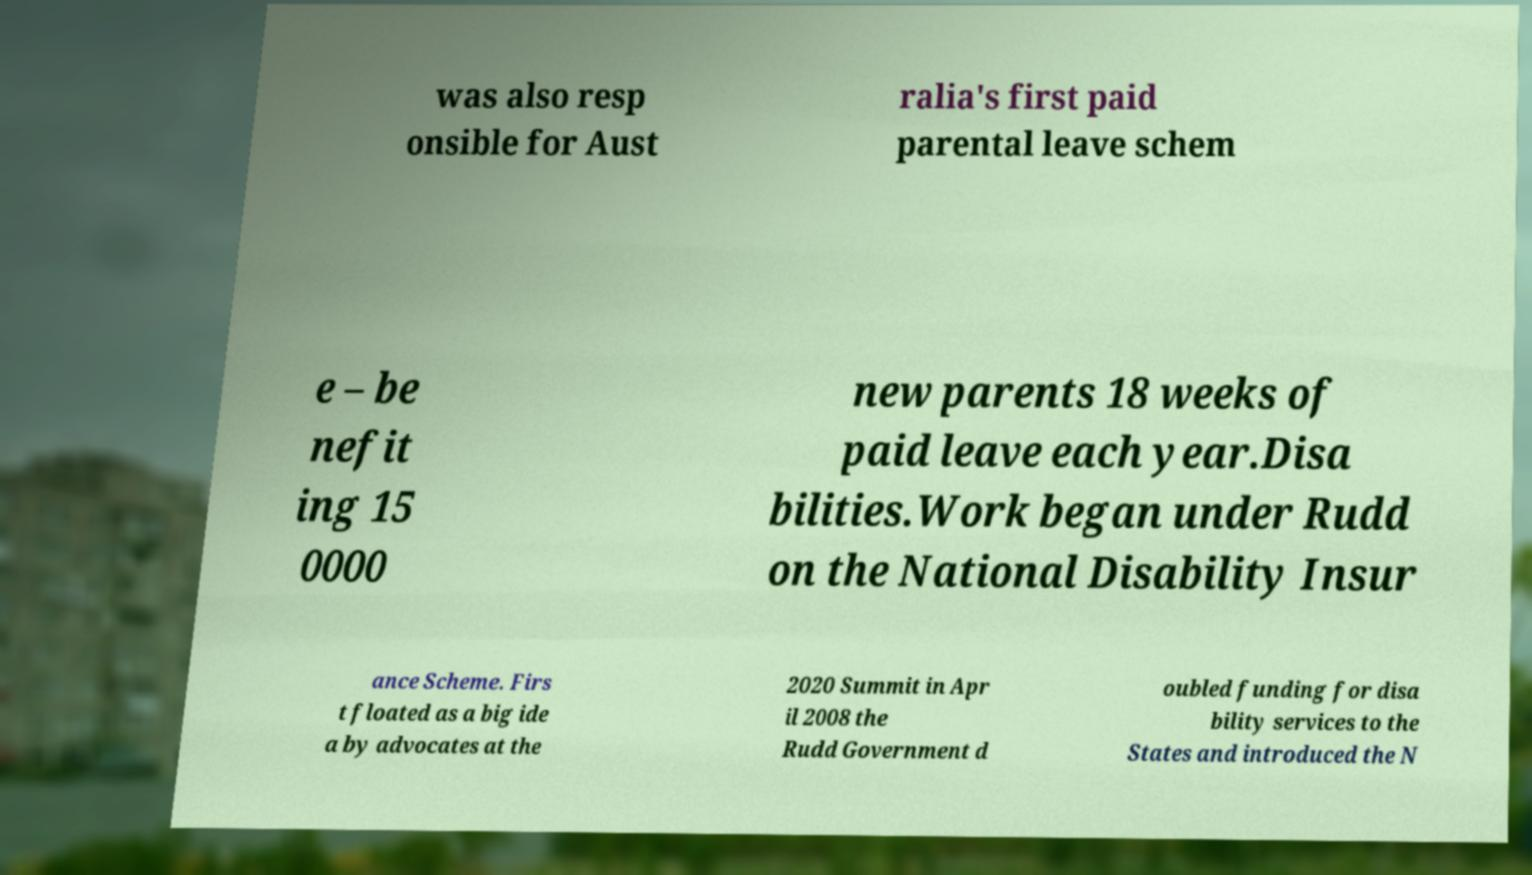Please read and relay the text visible in this image. What does it say? was also resp onsible for Aust ralia's first paid parental leave schem e – be nefit ing 15 0000 new parents 18 weeks of paid leave each year.Disa bilities.Work began under Rudd on the National Disability Insur ance Scheme. Firs t floated as a big ide a by advocates at the 2020 Summit in Apr il 2008 the Rudd Government d oubled funding for disa bility services to the States and introduced the N 